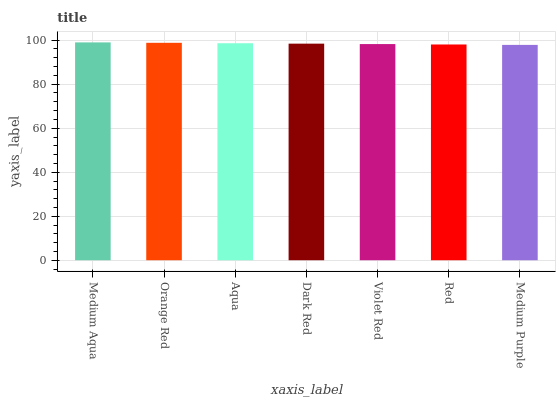Is Medium Purple the minimum?
Answer yes or no. Yes. Is Medium Aqua the maximum?
Answer yes or no. Yes. Is Orange Red the minimum?
Answer yes or no. No. Is Orange Red the maximum?
Answer yes or no. No. Is Medium Aqua greater than Orange Red?
Answer yes or no. Yes. Is Orange Red less than Medium Aqua?
Answer yes or no. Yes. Is Orange Red greater than Medium Aqua?
Answer yes or no. No. Is Medium Aqua less than Orange Red?
Answer yes or no. No. Is Dark Red the high median?
Answer yes or no. Yes. Is Dark Red the low median?
Answer yes or no. Yes. Is Aqua the high median?
Answer yes or no. No. Is Orange Red the low median?
Answer yes or no. No. 